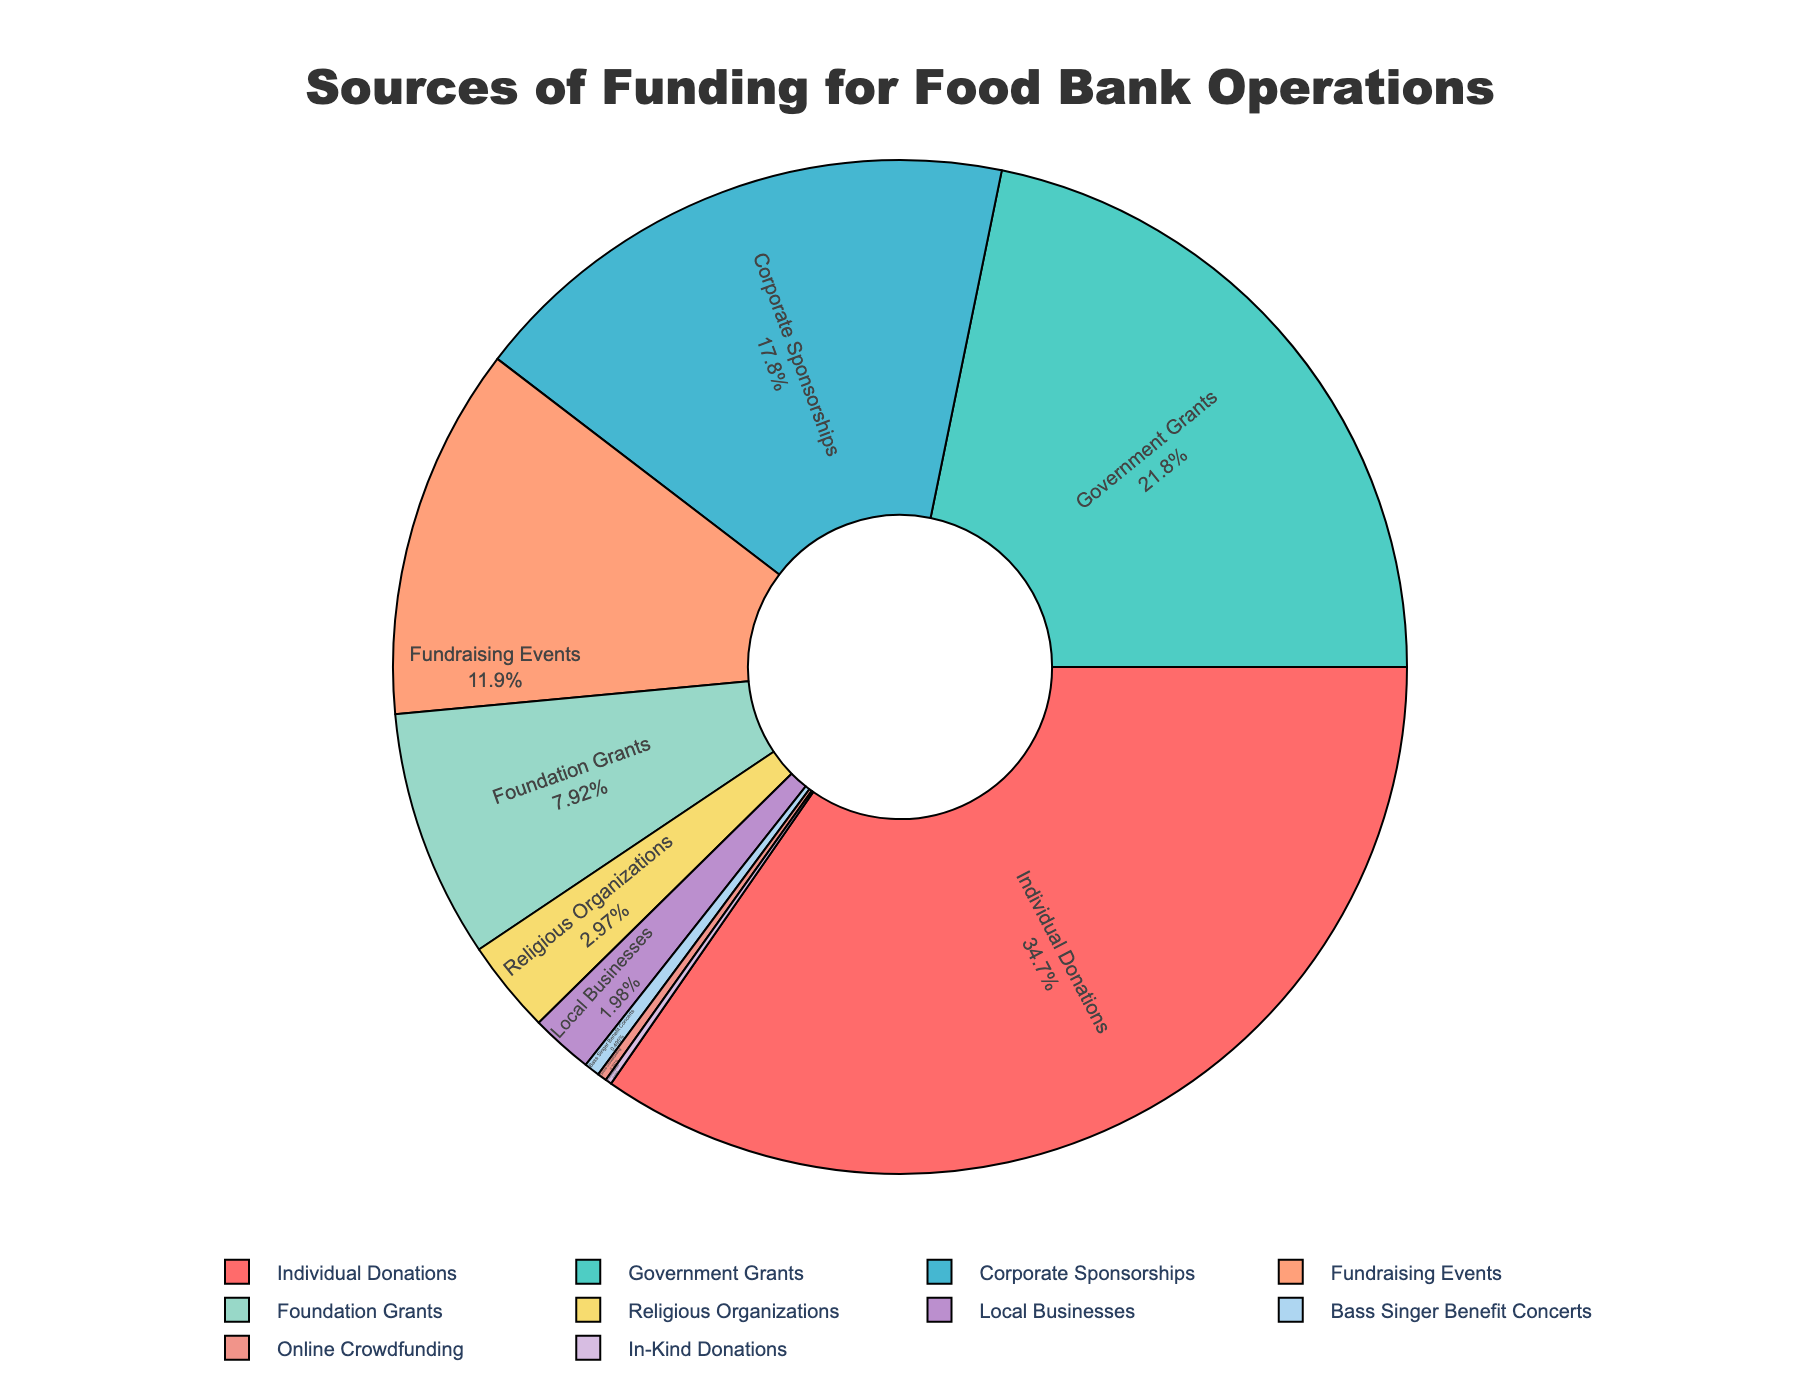Which source contributes the highest percentage of funding? The figure shows the segments labeled with both the source and the percentage. The largest segment is labeled 'Individual Donations' with 35%.
Answer: Individual Donations What is the combined percentage of funding from Government Grants and Corporate Sponsorships? The figure shows the segments labeled 'Government Grants' and 'Corporate Sponsorships' with 22% and 18% respectively. Adding them together, 22% + 18% = 40%.
Answer: 40% Which sources contribute less than 1% individually? The figure has small segments labeled 'Bass Singer Benefit Concerts', 'Online Crowdfunding', and 'In-Kind Donations' with 0.5%, 0.3%, and 0.2% respectively.
Answer: Bass Singer Benefit Concerts, Online Crowdfunding, In-Kind Donations How much more does Individual Donations contribute compared to Fundraising Events? The figure shows Individual Donations at 35% and Fundraising Events at 12%. The difference is 35% - 12% = 23%.
Answer: 23% Which two categories of funding have the smallest contributions? The figure shows the smallest segments labeled 'In-Kind Donations' and 'Online Crowdfunding' with 0.2% and 0.3% respectively.
Answer: In-Kind Donations, Online Crowdfunding By what percentage does Corporate Sponsorships exceed Foundation Grants? Corporate Sponsorships are at 18% and Foundation Grants are at 8%. The difference is 18% - 8% = 10%.
Answer: 10% Among the categories contributing between 5% and 25%, which one has the highest percentage? Government Grants (22%), Corporate Sponsorships (18%), and Fundraising Events (12%) fit this range. Government Grants have the highest percentage at 22%.
Answer: Government Grants What is the average percentage contribution of the sources contributing more than 20%? The sources contributing more than 20% are Individual Donations (35%) and Government Grants (22%). The average is (35% + 22%) / 2 = 28.5%.
Answer: 28.5% Is the contribution from Religious Organizations greater than Local Businesses? The figure shows Religious Organizations contribute 3% while Local Businesses contribute 2%. Since 3% > 2%, Religious Organizations contribute more.
Answer: Yes What is the total percentage contributed by Foundation Grants, Religious Organizations, and Local Businesses combined? The respective percentages are Foundation Grants (8%), Religious Organizations (3%), and Local Businesses (2%). Summing them up, 8% + 3% + 2% = 13%.
Answer: 13% 